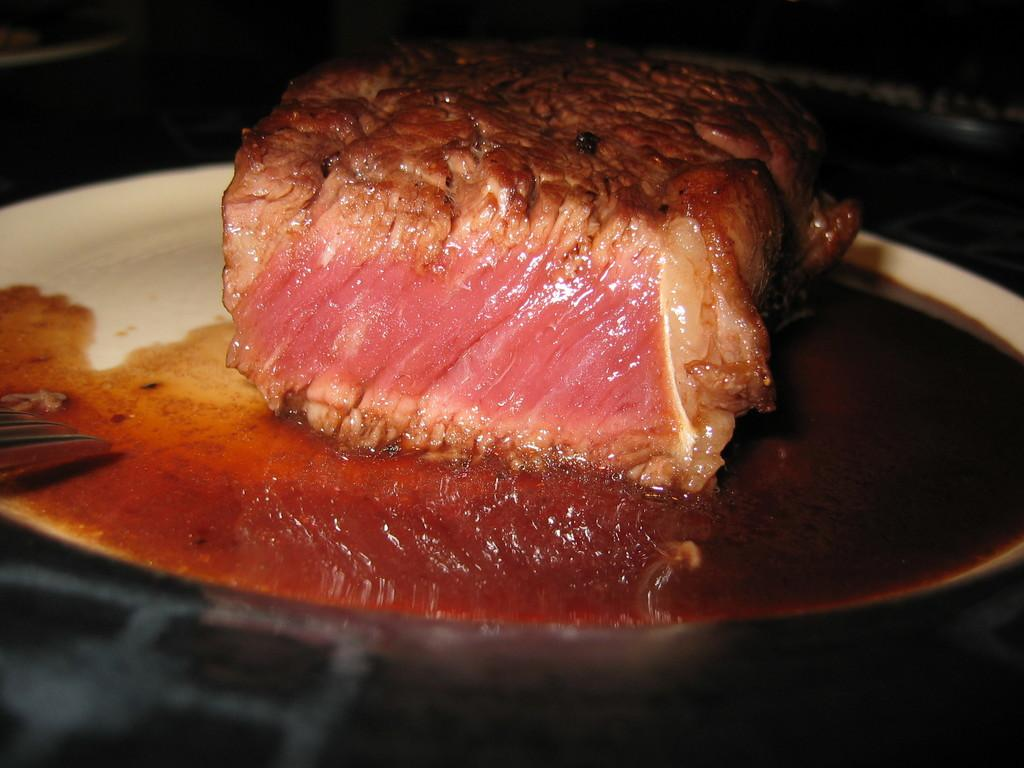What type of food is visible in the image? There is fried meat in the image. What can be seen on the plate with the fried meat? There is oil on the plate in the image. Where is the plate with the fried meat located? The plate is kept on a table. What type of branch is growing out of the fried meat in the image? There is no branch growing out of the fried meat in the image. 